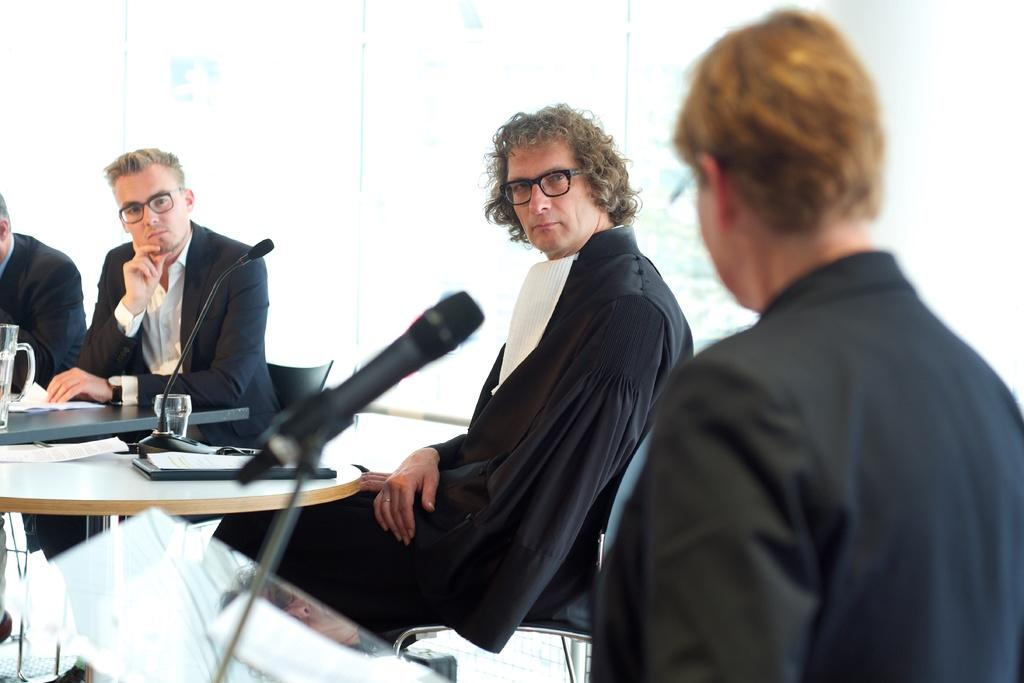What are the persons in the image doing? The persons in the image are sitting on chairs. What object is in front of the man? There is a microphone in front of a man. What items can be seen on the table in the image? There are glasses, a paper, and a jug on a table. What type of collar is the man wearing in the image? There is no collar visible in the image, as the man is not wearing any clothing. What degree is the person holding in the image? There is no person holding a degree in the image; there is only a paper on the table. 